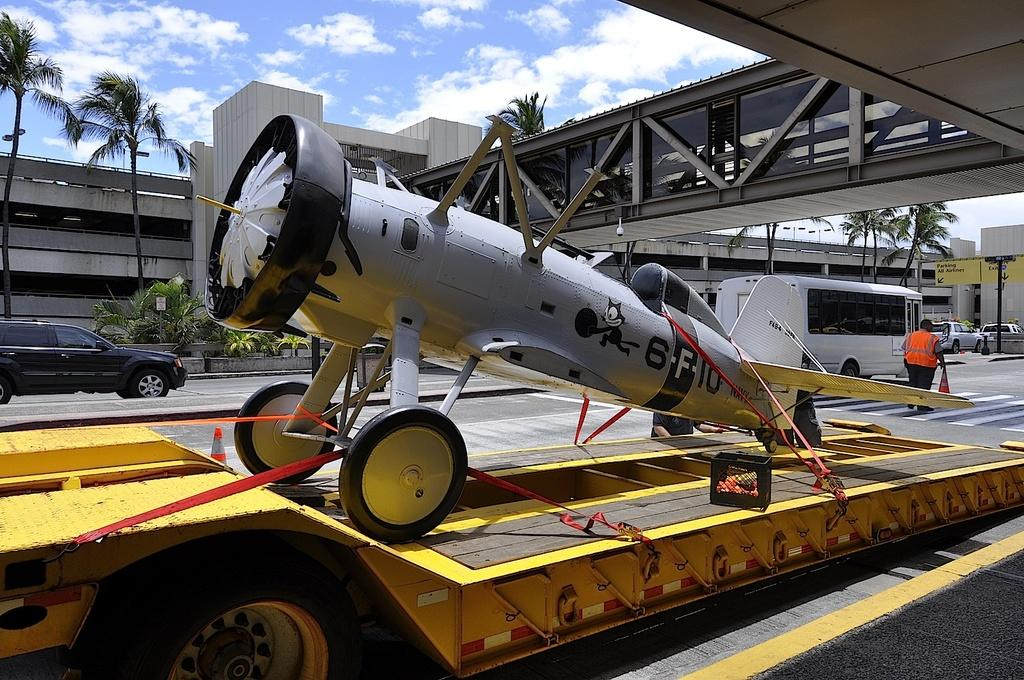Provide a one-sentence caption for the provided image. Airplane sitting on the trailer with the call letters 6-F-10. 